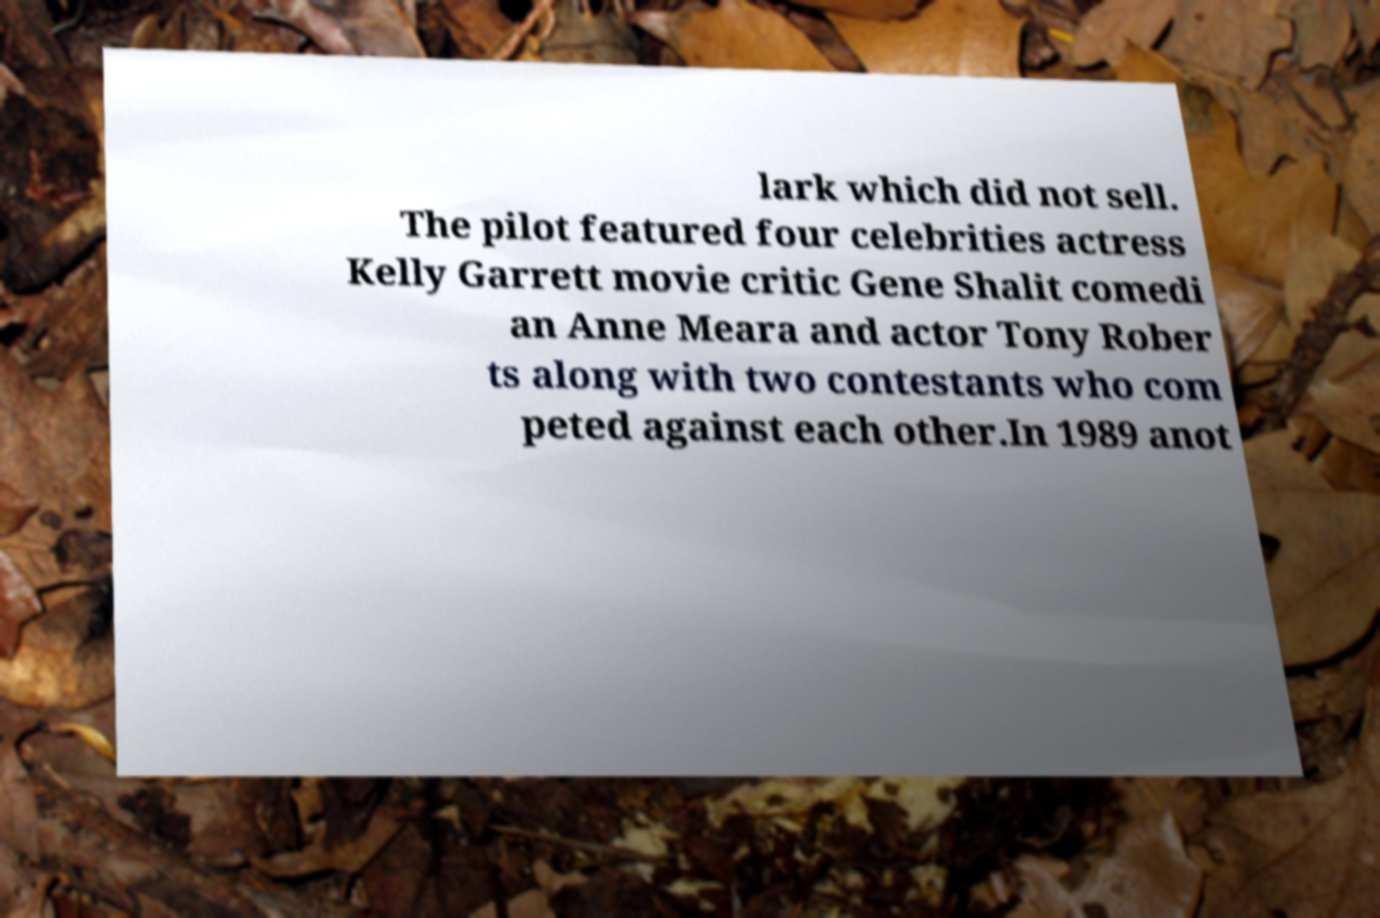Could you extract and type out the text from this image? lark which did not sell. The pilot featured four celebrities actress Kelly Garrett movie critic Gene Shalit comedi an Anne Meara and actor Tony Rober ts along with two contestants who com peted against each other.In 1989 anot 